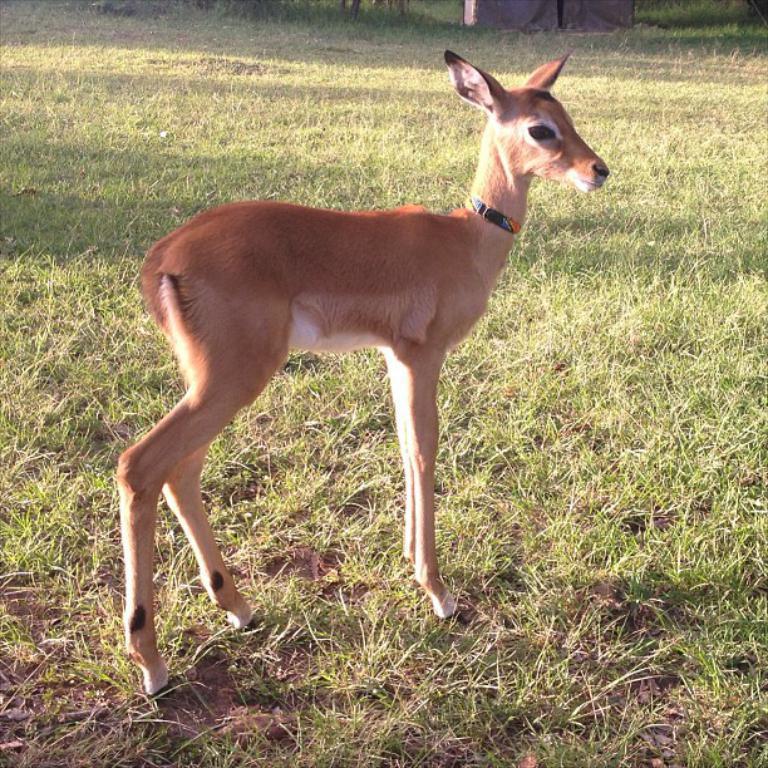Can you describe this image briefly? In the center of the picture there is a deer. In this picture there is grass and soil. At the top there is an object. 